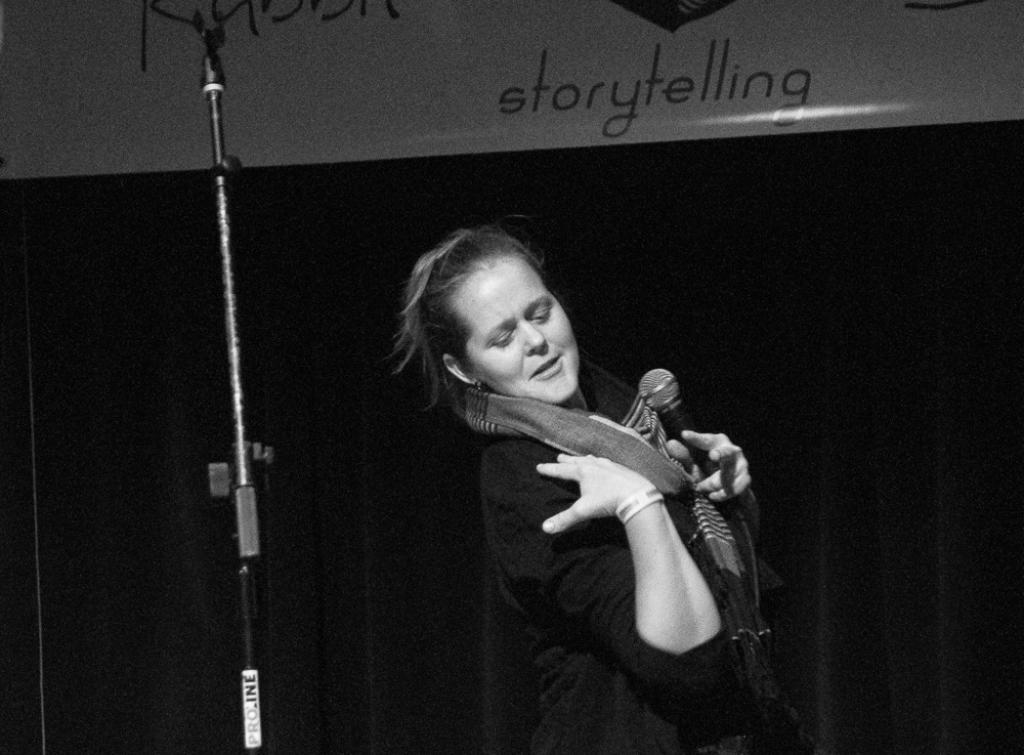Who is the main subject in the image? There is a woman in the image. What is the woman wearing? The woman is wearing a black t-shirt. What is the woman holding in the image? The woman is holding a microphone. What can be seen in the background of the image? The background of the image is dark. What object is located beside the woman? There is a stand beside the woman. What type of poison is the woman using in the image? There is no poison present in the image; the woman is holding a microphone. Can you describe the field where the woman is standing in the image? There is no field present in the image; the background is dark. 